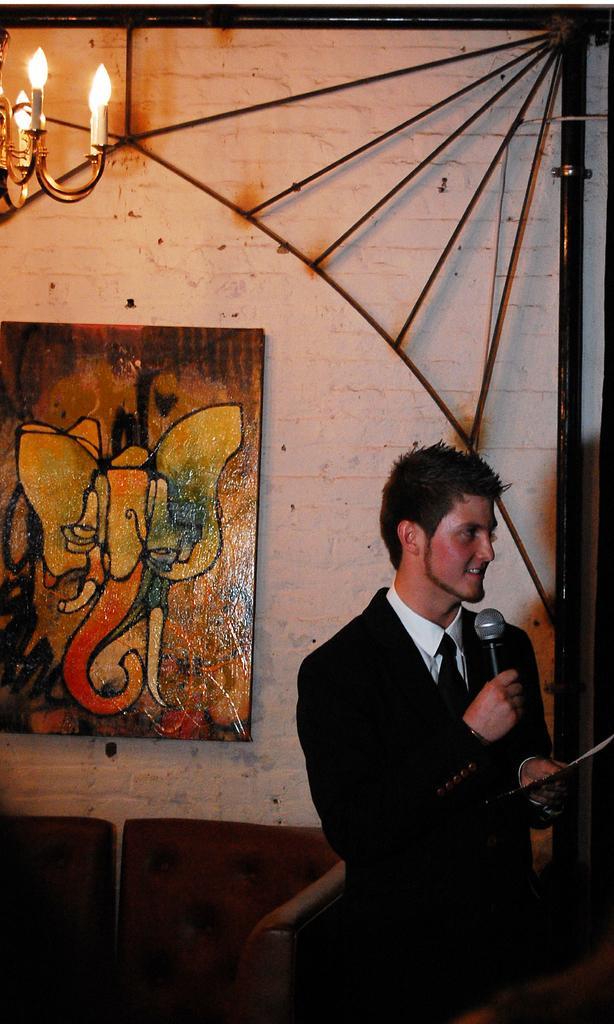Can you describe this image briefly? On the right side there is a man holding a mic and some other thing on the hand. In the back there are chairs and a wall with photo frames. Also there is a pole with rods. In the left top corner there is a chandelier. 